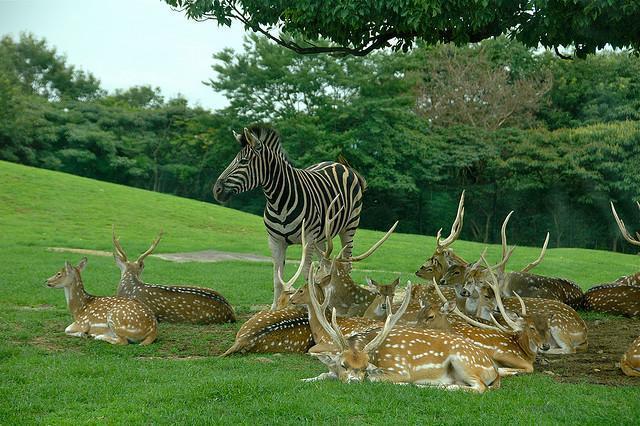How many people are wearing white shirt?
Give a very brief answer. 0. 